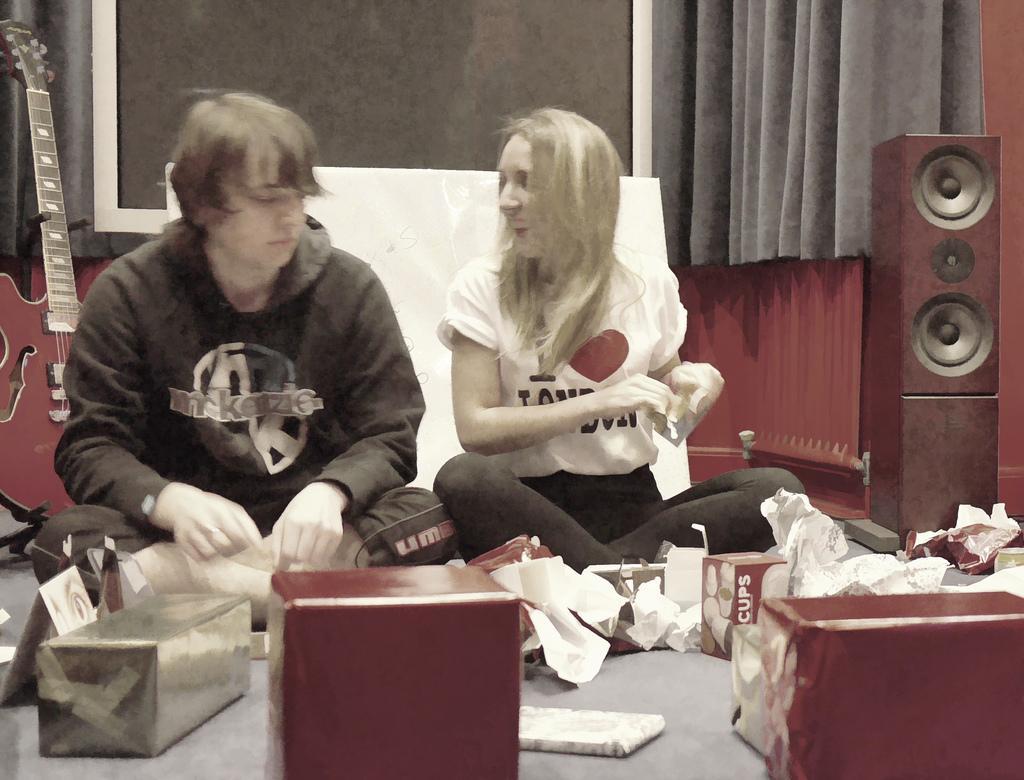Could you give a brief overview of what you see in this image? In this image we can see a man and a woman sitting on the floor. Here we can see boxes, papers, guitar, speaker, and other objects on the floor. In the background we can see a screen, curtain, and wall. 